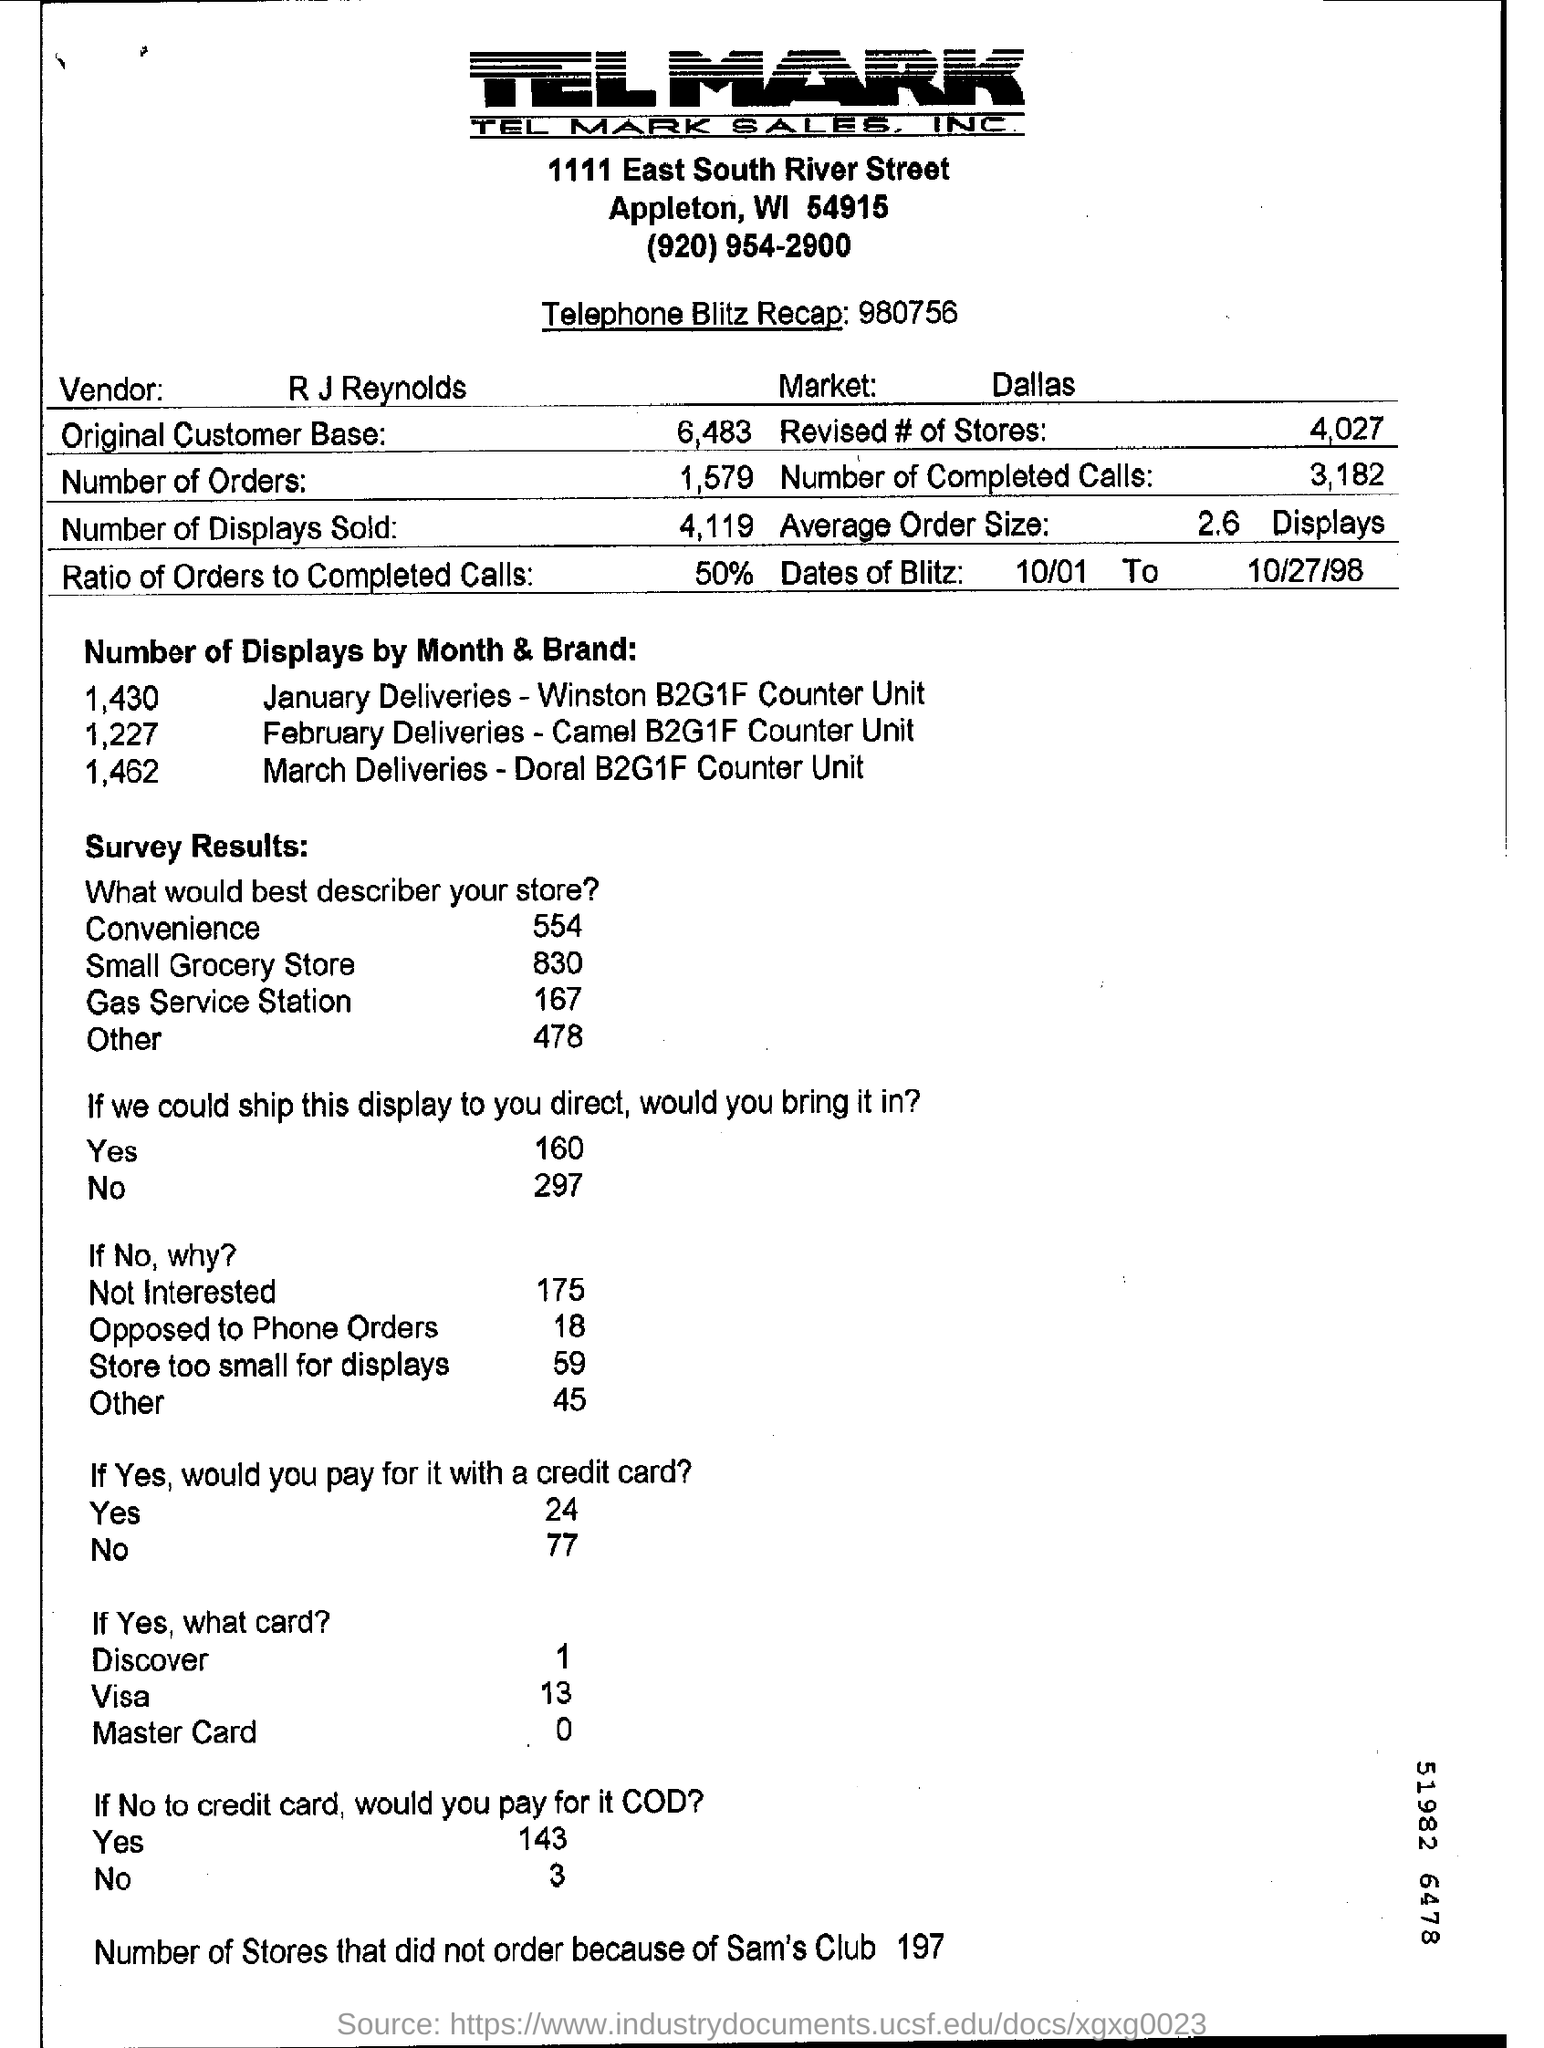Point out several critical features in this image. The ratio of orders to completed calls is approximately 50%. There were 1579 orders. The vendor is R.J. Reynolds. 